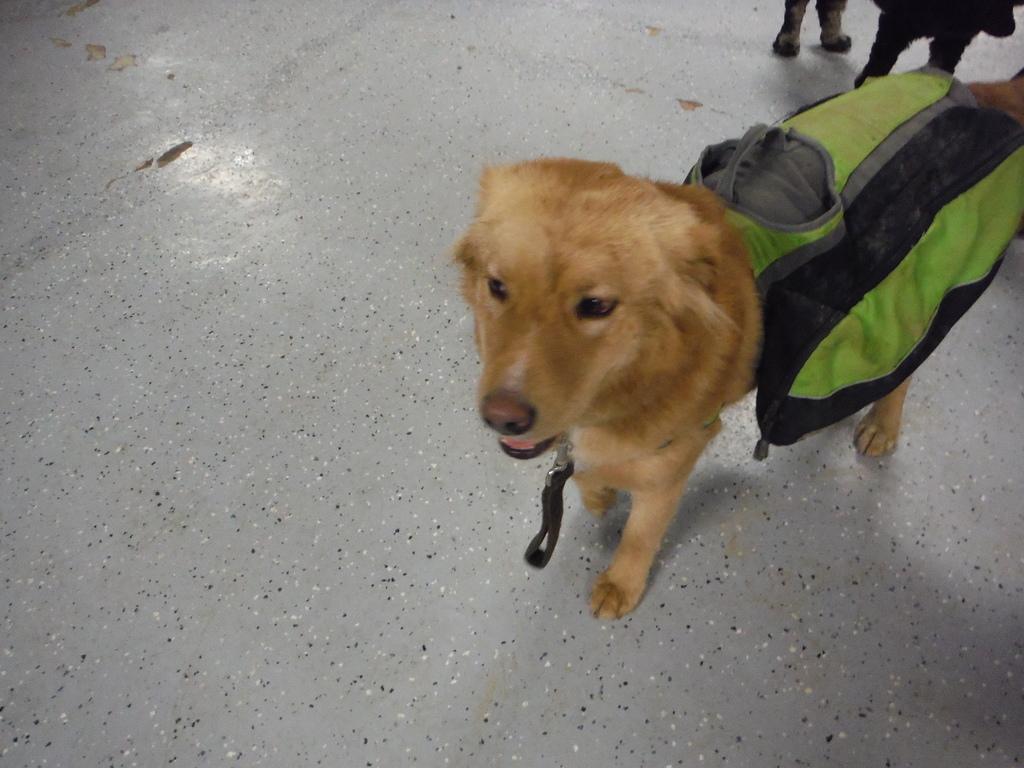Can you describe this image briefly? In the picture we can see a dog standing on the floor, the dog is cream in color and at the back of the dog we can see a some cover which is green in color and behind the dog we can see another dog standing which is black in color. 